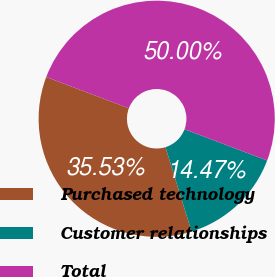Convert chart. <chart><loc_0><loc_0><loc_500><loc_500><pie_chart><fcel>Purchased technology<fcel>Customer relationships<fcel>Total<nl><fcel>35.53%<fcel>14.47%<fcel>50.0%<nl></chart> 